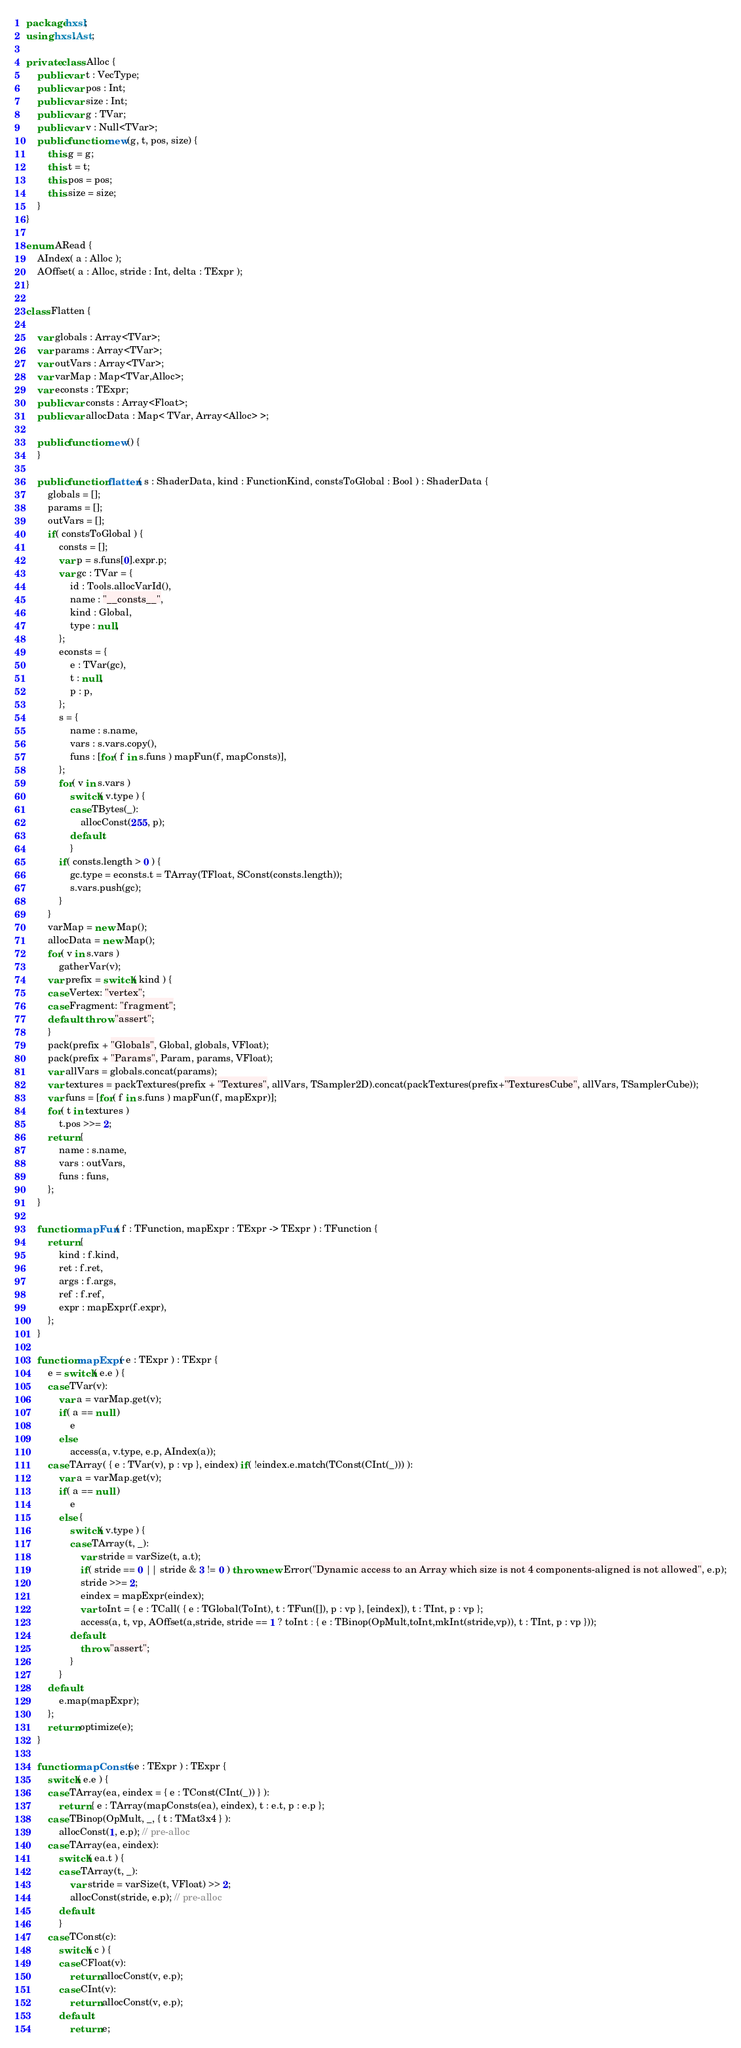<code> <loc_0><loc_0><loc_500><loc_500><_Haxe_>package hxsl;
using hxsl.Ast;

private class Alloc {
	public var t : VecType;
	public var pos : Int;
	public var size : Int;
	public var g : TVar;
	public var v : Null<TVar>;
	public function new(g, t, pos, size) {
		this.g = g;
		this.t = t;
		this.pos = pos;
		this.size = size;
	}
}

enum ARead {
	AIndex( a : Alloc );
	AOffset( a : Alloc, stride : Int, delta : TExpr );
}

class Flatten {

	var globals : Array<TVar>;
	var params : Array<TVar>;
	var outVars : Array<TVar>;
	var varMap : Map<TVar,Alloc>;
	var econsts : TExpr;
	public var consts : Array<Float>;
	public var allocData : Map< TVar, Array<Alloc> >;

	public function new() {
	}

	public function flatten( s : ShaderData, kind : FunctionKind, constsToGlobal : Bool ) : ShaderData {
		globals = [];
		params = [];
		outVars = [];
		if( constsToGlobal ) {
			consts = [];
			var p = s.funs[0].expr.p;
			var gc : TVar = {
				id : Tools.allocVarId(),
				name : "__consts__",
				kind : Global,
				type : null,
			};
			econsts = {
				e : TVar(gc),
				t : null,
				p : p,
			};
			s = {
				name : s.name,
				vars : s.vars.copy(),
				funs : [for( f in s.funs ) mapFun(f, mapConsts)],
			};
			for( v in s.vars )
				switch( v.type ) {
				case TBytes(_):
					allocConst(255, p);
				default:
				}
			if( consts.length > 0 ) {
				gc.type = econsts.t = TArray(TFloat, SConst(consts.length));
				s.vars.push(gc);
			}
		}
		varMap = new Map();
		allocData = new Map();
		for( v in s.vars )
			gatherVar(v);
		var prefix = switch( kind ) {
		case Vertex: "vertex";
		case Fragment: "fragment";
		default: throw "assert";
		}
		pack(prefix + "Globals", Global, globals, VFloat);
		pack(prefix + "Params", Param, params, VFloat);
		var allVars = globals.concat(params);
		var textures = packTextures(prefix + "Textures", allVars, TSampler2D).concat(packTextures(prefix+"TexturesCube", allVars, TSamplerCube));
		var funs = [for( f in s.funs ) mapFun(f, mapExpr)];
		for( t in textures )
			t.pos >>= 2;
		return {
			name : s.name,
			vars : outVars,
			funs : funs,
		};
	}

	function mapFun( f : TFunction, mapExpr : TExpr -> TExpr ) : TFunction {
		return {
			kind : f.kind,
			ret : f.ret,
			args : f.args,
			ref : f.ref,
			expr : mapExpr(f.expr),
		};
	}

	function mapExpr( e : TExpr ) : TExpr {
		e = switch( e.e ) {
		case TVar(v):
			var a = varMap.get(v);
			if( a == null )
				e
			else
				access(a, v.type, e.p, AIndex(a));
		case TArray( { e : TVar(v), p : vp }, eindex) if( !eindex.e.match(TConst(CInt(_))) ):
			var a = varMap.get(v);
			if( a == null )
				e
			else {
				switch( v.type ) {
				case TArray(t, _):
					var stride = varSize(t, a.t);
					if( stride == 0 || stride & 3 != 0 ) throw new Error("Dynamic access to an Array which size is not 4 components-aligned is not allowed", e.p);
					stride >>= 2;
					eindex = mapExpr(eindex);
					var toInt = { e : TCall( { e : TGlobal(ToInt), t : TFun([]), p : vp }, [eindex]), t : TInt, p : vp };
					access(a, t, vp, AOffset(a,stride, stride == 1 ? toInt : { e : TBinop(OpMult,toInt,mkInt(stride,vp)), t : TInt, p : vp }));
				default:
					throw "assert";
				}
			}
		default:
			e.map(mapExpr);
		};
		return optimize(e);
	}

	function mapConsts( e : TExpr ) : TExpr {
		switch( e.e ) {
		case TArray(ea, eindex = { e : TConst(CInt(_)) } ):
			return { e : TArray(mapConsts(ea), eindex), t : e.t, p : e.p };
		case TBinop(OpMult, _, { t : TMat3x4 } ):
			allocConst(1, e.p); // pre-alloc
		case TArray(ea, eindex):
			switch( ea.t ) {
			case TArray(t, _):
				var stride = varSize(t, VFloat) >> 2;
				allocConst(stride, e.p); // pre-alloc
			default:
			}
		case TConst(c):
			switch( c ) {
			case CFloat(v):
				return allocConst(v, e.p);
			case CInt(v):
				return allocConst(v, e.p);
			default:
				return e;</code> 